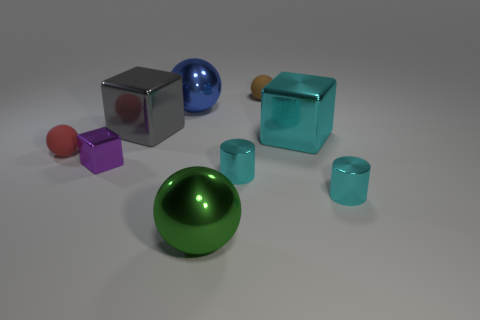Subtract 1 spheres. How many spheres are left? 3 Subtract all cyan spheres. Subtract all purple cubes. How many spheres are left? 4 Add 1 big gray shiny blocks. How many objects exist? 10 Subtract all cubes. How many objects are left? 6 Add 4 cyan shiny blocks. How many cyan shiny blocks are left? 5 Add 7 big blue things. How many big blue things exist? 8 Subtract 0 red cubes. How many objects are left? 9 Subtract all small cyan metal spheres. Subtract all large gray things. How many objects are left? 8 